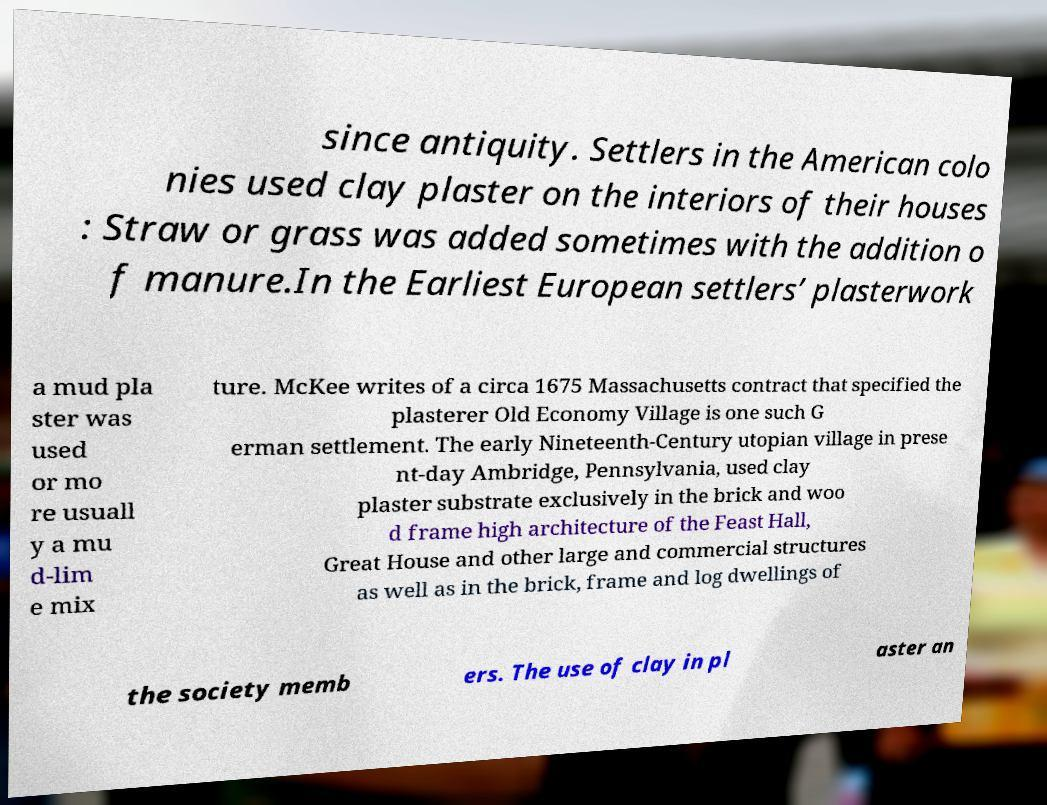Can you read and provide the text displayed in the image?This photo seems to have some interesting text. Can you extract and type it out for me? since antiquity. Settlers in the American colo nies used clay plaster on the interiors of their houses : Straw or grass was added sometimes with the addition o f manure.In the Earliest European settlers’ plasterwork a mud pla ster was used or mo re usuall y a mu d-lim e mix ture. McKee writes of a circa 1675 Massachusetts contract that specified the plasterer Old Economy Village is one such G erman settlement. The early Nineteenth-Century utopian village in prese nt-day Ambridge, Pennsylvania, used clay plaster substrate exclusively in the brick and woo d frame high architecture of the Feast Hall, Great House and other large and commercial structures as well as in the brick, frame and log dwellings of the society memb ers. The use of clay in pl aster an 